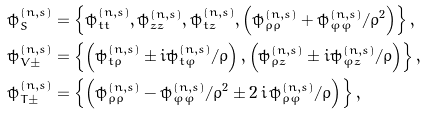Convert formula to latex. <formula><loc_0><loc_0><loc_500><loc_500>\tilde { \psi } _ { S } ^ { ( n , s ) } & = \left \{ \tilde { \psi } _ { t t } ^ { ( n , s ) } , \tilde { \psi } _ { z z } ^ { ( n , s ) } , \tilde { \psi } _ { t z } ^ { ( n , s ) } , \left ( \tilde { \psi } _ { \rho \rho } ^ { ( n , s ) } + \tilde { \psi } _ { \varphi \varphi } ^ { ( n , s ) } / \rho ^ { 2 } \right ) \right \} , \\ \tilde { \psi } _ { V \pm } ^ { ( n , s ) } & = \left \{ \left ( \tilde { \psi } _ { t \rho } ^ { ( n , s ) } \pm i \tilde { \psi } _ { t \varphi } ^ { ( n , s ) } / \rho \right ) , \left ( \tilde { \psi } _ { \rho z } ^ { ( n , s ) } \pm i \tilde { \psi } _ { \varphi z } ^ { ( n , s ) } / \rho \right ) \right \} , \\ \tilde { \psi } _ { T \pm } ^ { ( n , s ) } & = \left \{ \left ( \tilde { \psi } _ { \rho \rho } ^ { ( n , s ) } - \tilde { \psi } _ { \varphi \varphi } ^ { ( n , s ) } / \rho ^ { 2 } \pm 2 \, i \, \tilde { \psi } _ { \rho \varphi } ^ { ( n , s ) } / \rho \right ) \right \} ,</formula> 